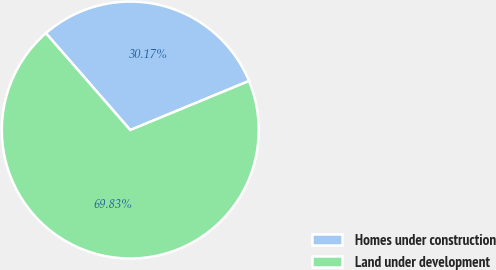Convert chart to OTSL. <chart><loc_0><loc_0><loc_500><loc_500><pie_chart><fcel>Homes under construction<fcel>Land under development<nl><fcel>30.17%<fcel>69.83%<nl></chart> 